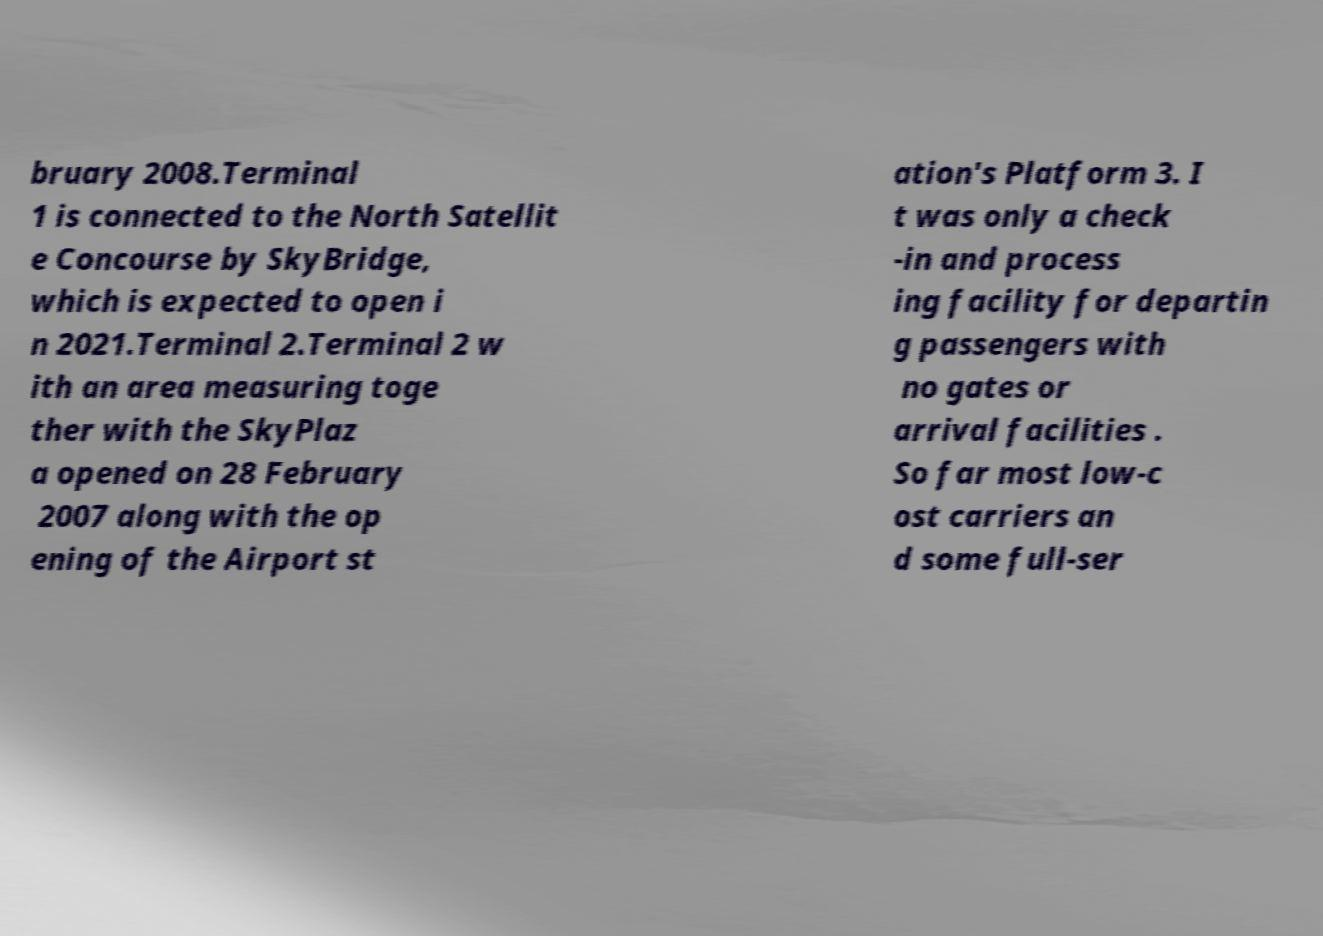Please identify and transcribe the text found in this image. bruary 2008.Terminal 1 is connected to the North Satellit e Concourse by SkyBridge, which is expected to open i n 2021.Terminal 2.Terminal 2 w ith an area measuring toge ther with the SkyPlaz a opened on 28 February 2007 along with the op ening of the Airport st ation's Platform 3. I t was only a check -in and process ing facility for departin g passengers with no gates or arrival facilities . So far most low-c ost carriers an d some full-ser 